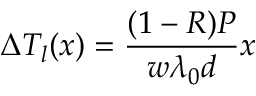Convert formula to latex. <formula><loc_0><loc_0><loc_500><loc_500>\Delta T _ { l } ( x ) = \frac { ( 1 - R ) P } { w \lambda _ { 0 } d } x</formula> 